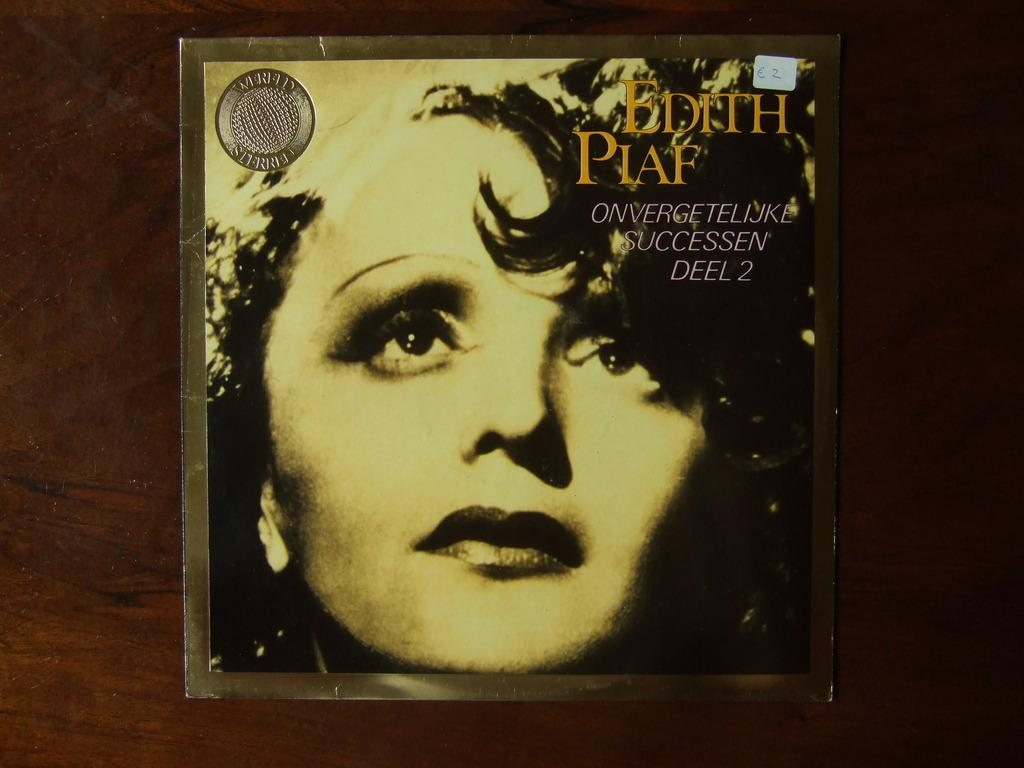What is the main subject in the center of the image? There is a poster in the center of the image. What can be found on the poster? The poster contains text and a face of a person. What is the color of the surface the poster is on? The poster is on a brown-colored surface. How many eggs are being used by the laborer in the image? There are no eggs or laborers present in the image; it features a poster with text and a person's face on a brown-colored surface. 